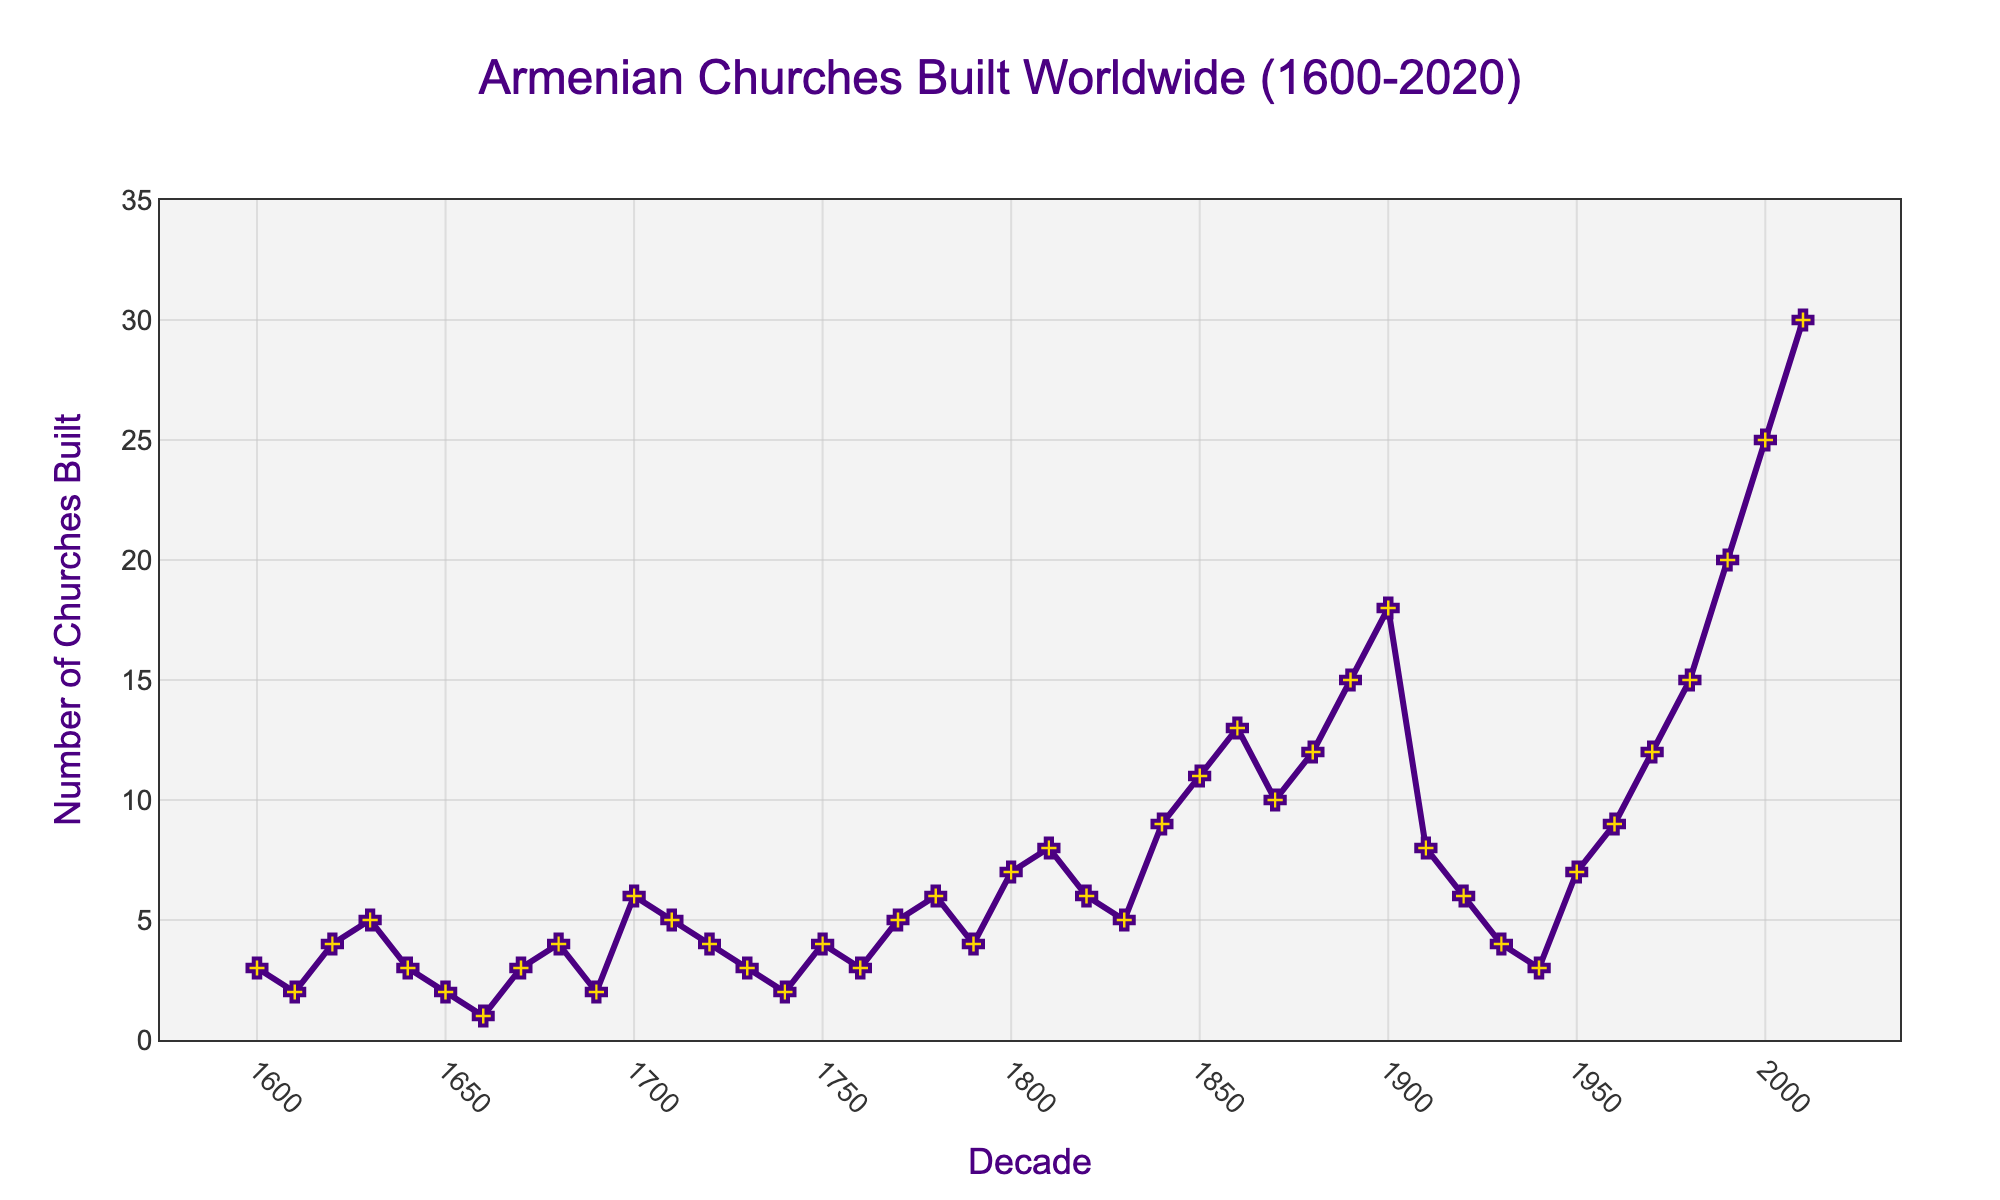How many Armenian churches were built in the decade starting in 1700? Locate the point corresponding to the decade starting in 1700 and read the y-axis value, which is 6.
Answer: 6 Which decade saw the highest number of Armenian churches built? Find the highest point on the line plot. The decade starting in 2010 has the highest y-value, which is 30.
Answer: 2010-2020 During which decade did the number of churches built decline sharply after a previous peak, and by how much did it decline? Identify the peak before a sharp decline; the decade starting in 1900 has 18 churches and the next decade, 1910-1920, has 8 churches. The decline is 18 - 8 = 10.
Answer: 1910-1920, by 10 Compare the number of churches built in the decades of 1800 and 1900 and determine which one had more and by how much. Find the y-values for both decades: 1800-1810 has 7 and 1900-1910 has 18. The difference is 18 - 7 = 11.
Answer: 1900-1910, by 11 What is the general trend of the number of churches built from 1600 to 2020? Observe the overall shape of the line. The number of churches built shows an initial fluctuation with moderate increases and decreases until the late 19th century, followed by an overall upward trend from the 1900s onwards, peaking after 2000.
Answer: Upward trend How does the number of churches built in the decade starting in 1950 compare to that in 1980? Identify the y-values: 1950-1960 has 7 churches and 1980-1990 has 15 churches. 15 is greater than 7.
Answer: 1980-1990 had more In which decade between 1600 and 1700 did the least number of churches get built, and how many were built? Scan between 1600 and 1700. The lowest point is in the decade 1660-1670 with 1 church built.
Answer: 1660-1670, 1 church Calculate the increase in the number of churches built from the decade of 1940 to the decade of 1950. Find the y-values: 1940-1950 has 3 churches and 1950-1960 has 7 churches. The increase is 7 - 3 = 4.
Answer: Increase by 4 Which decades saw exactly 4 Armenian churches built? Look for points on the y-axis where the value is 4. The decades are 1620-1630, 1680-1690, 1720-1730, 1790-1800, and 1930-1940.
Answer: 1620-1630, 1680-1690, 1720-1730, 1790-1800, 1930-1940 